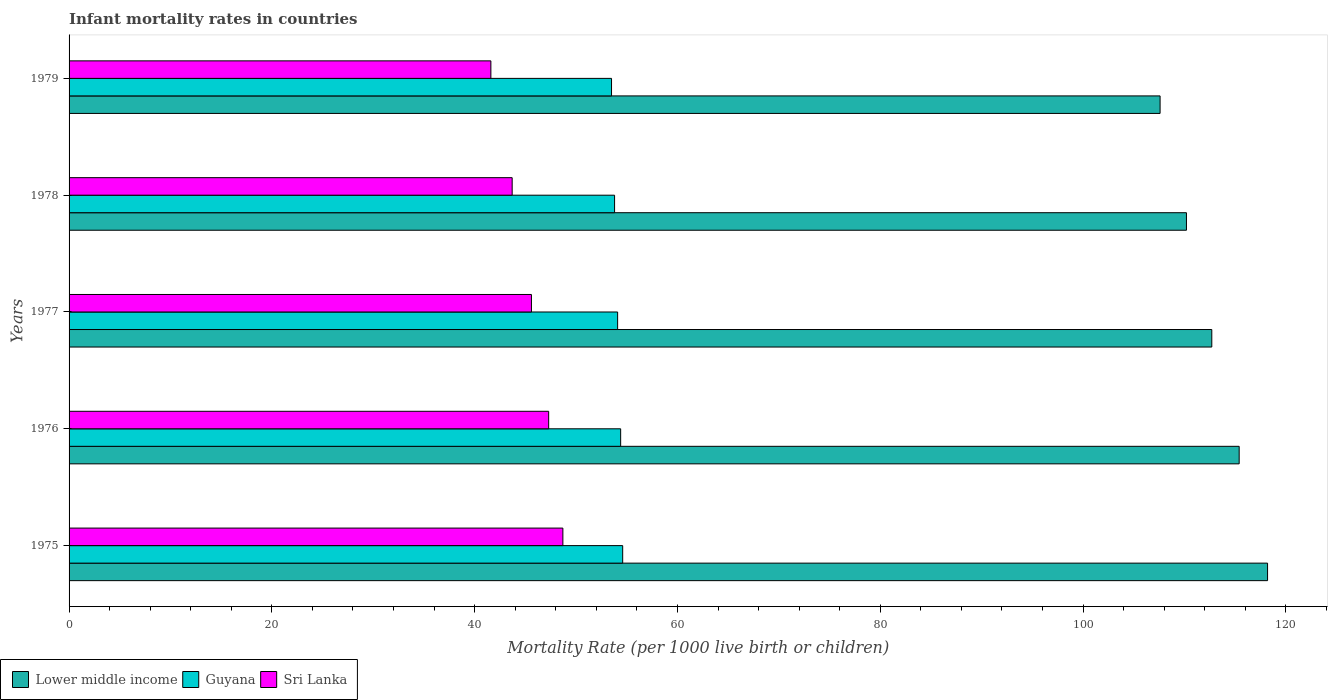How many different coloured bars are there?
Make the answer very short. 3. Are the number of bars per tick equal to the number of legend labels?
Your answer should be compact. Yes. How many bars are there on the 4th tick from the top?
Your answer should be very brief. 3. How many bars are there on the 4th tick from the bottom?
Make the answer very short. 3. What is the label of the 4th group of bars from the top?
Provide a succinct answer. 1976. What is the infant mortality rate in Guyana in 1978?
Offer a terse response. 53.8. Across all years, what is the maximum infant mortality rate in Lower middle income?
Offer a very short reply. 118.2. Across all years, what is the minimum infant mortality rate in Guyana?
Provide a short and direct response. 53.5. In which year was the infant mortality rate in Sri Lanka maximum?
Keep it short and to the point. 1975. In which year was the infant mortality rate in Lower middle income minimum?
Your answer should be very brief. 1979. What is the total infant mortality rate in Lower middle income in the graph?
Give a very brief answer. 564.1. What is the difference between the infant mortality rate in Guyana in 1975 and the infant mortality rate in Sri Lanka in 1976?
Offer a very short reply. 7.3. What is the average infant mortality rate in Lower middle income per year?
Your response must be concise. 112.82. In the year 1979, what is the difference between the infant mortality rate in Guyana and infant mortality rate in Sri Lanka?
Offer a terse response. 11.9. In how many years, is the infant mortality rate in Sri Lanka greater than 72 ?
Your answer should be compact. 0. What is the ratio of the infant mortality rate in Sri Lanka in 1977 to that in 1978?
Provide a short and direct response. 1.04. Is the infant mortality rate in Sri Lanka in 1978 less than that in 1979?
Your answer should be very brief. No. What is the difference between the highest and the second highest infant mortality rate in Lower middle income?
Your answer should be very brief. 2.8. What is the difference between the highest and the lowest infant mortality rate in Lower middle income?
Offer a very short reply. 10.6. What does the 2nd bar from the top in 1976 represents?
Your answer should be compact. Guyana. What does the 3rd bar from the bottom in 1976 represents?
Keep it short and to the point. Sri Lanka. What is the difference between two consecutive major ticks on the X-axis?
Keep it short and to the point. 20. Does the graph contain grids?
Your answer should be very brief. No. How many legend labels are there?
Offer a very short reply. 3. What is the title of the graph?
Offer a very short reply. Infant mortality rates in countries. What is the label or title of the X-axis?
Provide a short and direct response. Mortality Rate (per 1000 live birth or children). What is the Mortality Rate (per 1000 live birth or children) of Lower middle income in 1975?
Provide a short and direct response. 118.2. What is the Mortality Rate (per 1000 live birth or children) of Guyana in 1975?
Provide a succinct answer. 54.6. What is the Mortality Rate (per 1000 live birth or children) of Sri Lanka in 1975?
Give a very brief answer. 48.7. What is the Mortality Rate (per 1000 live birth or children) in Lower middle income in 1976?
Offer a terse response. 115.4. What is the Mortality Rate (per 1000 live birth or children) in Guyana in 1976?
Ensure brevity in your answer.  54.4. What is the Mortality Rate (per 1000 live birth or children) in Sri Lanka in 1976?
Give a very brief answer. 47.3. What is the Mortality Rate (per 1000 live birth or children) of Lower middle income in 1977?
Ensure brevity in your answer.  112.7. What is the Mortality Rate (per 1000 live birth or children) in Guyana in 1977?
Your answer should be very brief. 54.1. What is the Mortality Rate (per 1000 live birth or children) in Sri Lanka in 1977?
Give a very brief answer. 45.6. What is the Mortality Rate (per 1000 live birth or children) of Lower middle income in 1978?
Provide a short and direct response. 110.2. What is the Mortality Rate (per 1000 live birth or children) of Guyana in 1978?
Give a very brief answer. 53.8. What is the Mortality Rate (per 1000 live birth or children) in Sri Lanka in 1978?
Your answer should be compact. 43.7. What is the Mortality Rate (per 1000 live birth or children) in Lower middle income in 1979?
Offer a very short reply. 107.6. What is the Mortality Rate (per 1000 live birth or children) in Guyana in 1979?
Offer a very short reply. 53.5. What is the Mortality Rate (per 1000 live birth or children) in Sri Lanka in 1979?
Offer a very short reply. 41.6. Across all years, what is the maximum Mortality Rate (per 1000 live birth or children) in Lower middle income?
Provide a short and direct response. 118.2. Across all years, what is the maximum Mortality Rate (per 1000 live birth or children) in Guyana?
Ensure brevity in your answer.  54.6. Across all years, what is the maximum Mortality Rate (per 1000 live birth or children) in Sri Lanka?
Ensure brevity in your answer.  48.7. Across all years, what is the minimum Mortality Rate (per 1000 live birth or children) in Lower middle income?
Make the answer very short. 107.6. Across all years, what is the minimum Mortality Rate (per 1000 live birth or children) of Guyana?
Give a very brief answer. 53.5. Across all years, what is the minimum Mortality Rate (per 1000 live birth or children) of Sri Lanka?
Offer a terse response. 41.6. What is the total Mortality Rate (per 1000 live birth or children) in Lower middle income in the graph?
Provide a succinct answer. 564.1. What is the total Mortality Rate (per 1000 live birth or children) of Guyana in the graph?
Provide a short and direct response. 270.4. What is the total Mortality Rate (per 1000 live birth or children) in Sri Lanka in the graph?
Provide a short and direct response. 226.9. What is the difference between the Mortality Rate (per 1000 live birth or children) in Guyana in 1975 and that in 1976?
Your response must be concise. 0.2. What is the difference between the Mortality Rate (per 1000 live birth or children) in Sri Lanka in 1975 and that in 1976?
Offer a very short reply. 1.4. What is the difference between the Mortality Rate (per 1000 live birth or children) in Lower middle income in 1975 and that in 1977?
Offer a terse response. 5.5. What is the difference between the Mortality Rate (per 1000 live birth or children) in Guyana in 1975 and that in 1977?
Provide a succinct answer. 0.5. What is the difference between the Mortality Rate (per 1000 live birth or children) in Lower middle income in 1975 and that in 1978?
Make the answer very short. 8. What is the difference between the Mortality Rate (per 1000 live birth or children) of Guyana in 1975 and that in 1978?
Offer a very short reply. 0.8. What is the difference between the Mortality Rate (per 1000 live birth or children) of Sri Lanka in 1975 and that in 1978?
Your response must be concise. 5. What is the difference between the Mortality Rate (per 1000 live birth or children) in Lower middle income in 1975 and that in 1979?
Ensure brevity in your answer.  10.6. What is the difference between the Mortality Rate (per 1000 live birth or children) in Guyana in 1975 and that in 1979?
Offer a terse response. 1.1. What is the difference between the Mortality Rate (per 1000 live birth or children) in Lower middle income in 1976 and that in 1977?
Your response must be concise. 2.7. What is the difference between the Mortality Rate (per 1000 live birth or children) of Sri Lanka in 1976 and that in 1977?
Ensure brevity in your answer.  1.7. What is the difference between the Mortality Rate (per 1000 live birth or children) of Lower middle income in 1976 and that in 1978?
Your response must be concise. 5.2. What is the difference between the Mortality Rate (per 1000 live birth or children) of Guyana in 1976 and that in 1978?
Keep it short and to the point. 0.6. What is the difference between the Mortality Rate (per 1000 live birth or children) of Sri Lanka in 1976 and that in 1978?
Provide a short and direct response. 3.6. What is the difference between the Mortality Rate (per 1000 live birth or children) in Guyana in 1976 and that in 1979?
Give a very brief answer. 0.9. What is the difference between the Mortality Rate (per 1000 live birth or children) of Lower middle income in 1977 and that in 1978?
Offer a terse response. 2.5. What is the difference between the Mortality Rate (per 1000 live birth or children) in Guyana in 1977 and that in 1978?
Provide a succinct answer. 0.3. What is the difference between the Mortality Rate (per 1000 live birth or children) of Sri Lanka in 1977 and that in 1978?
Your answer should be compact. 1.9. What is the difference between the Mortality Rate (per 1000 live birth or children) of Lower middle income in 1977 and that in 1979?
Offer a very short reply. 5.1. What is the difference between the Mortality Rate (per 1000 live birth or children) in Lower middle income in 1978 and that in 1979?
Make the answer very short. 2.6. What is the difference between the Mortality Rate (per 1000 live birth or children) of Sri Lanka in 1978 and that in 1979?
Offer a terse response. 2.1. What is the difference between the Mortality Rate (per 1000 live birth or children) of Lower middle income in 1975 and the Mortality Rate (per 1000 live birth or children) of Guyana in 1976?
Ensure brevity in your answer.  63.8. What is the difference between the Mortality Rate (per 1000 live birth or children) of Lower middle income in 1975 and the Mortality Rate (per 1000 live birth or children) of Sri Lanka in 1976?
Your answer should be compact. 70.9. What is the difference between the Mortality Rate (per 1000 live birth or children) in Guyana in 1975 and the Mortality Rate (per 1000 live birth or children) in Sri Lanka in 1976?
Keep it short and to the point. 7.3. What is the difference between the Mortality Rate (per 1000 live birth or children) in Lower middle income in 1975 and the Mortality Rate (per 1000 live birth or children) in Guyana in 1977?
Your answer should be very brief. 64.1. What is the difference between the Mortality Rate (per 1000 live birth or children) in Lower middle income in 1975 and the Mortality Rate (per 1000 live birth or children) in Sri Lanka in 1977?
Offer a very short reply. 72.6. What is the difference between the Mortality Rate (per 1000 live birth or children) of Guyana in 1975 and the Mortality Rate (per 1000 live birth or children) of Sri Lanka in 1977?
Your answer should be very brief. 9. What is the difference between the Mortality Rate (per 1000 live birth or children) in Lower middle income in 1975 and the Mortality Rate (per 1000 live birth or children) in Guyana in 1978?
Give a very brief answer. 64.4. What is the difference between the Mortality Rate (per 1000 live birth or children) of Lower middle income in 1975 and the Mortality Rate (per 1000 live birth or children) of Sri Lanka in 1978?
Your answer should be very brief. 74.5. What is the difference between the Mortality Rate (per 1000 live birth or children) in Lower middle income in 1975 and the Mortality Rate (per 1000 live birth or children) in Guyana in 1979?
Your answer should be compact. 64.7. What is the difference between the Mortality Rate (per 1000 live birth or children) in Lower middle income in 1975 and the Mortality Rate (per 1000 live birth or children) in Sri Lanka in 1979?
Provide a succinct answer. 76.6. What is the difference between the Mortality Rate (per 1000 live birth or children) in Lower middle income in 1976 and the Mortality Rate (per 1000 live birth or children) in Guyana in 1977?
Offer a terse response. 61.3. What is the difference between the Mortality Rate (per 1000 live birth or children) of Lower middle income in 1976 and the Mortality Rate (per 1000 live birth or children) of Sri Lanka in 1977?
Offer a terse response. 69.8. What is the difference between the Mortality Rate (per 1000 live birth or children) of Lower middle income in 1976 and the Mortality Rate (per 1000 live birth or children) of Guyana in 1978?
Make the answer very short. 61.6. What is the difference between the Mortality Rate (per 1000 live birth or children) in Lower middle income in 1976 and the Mortality Rate (per 1000 live birth or children) in Sri Lanka in 1978?
Provide a succinct answer. 71.7. What is the difference between the Mortality Rate (per 1000 live birth or children) in Guyana in 1976 and the Mortality Rate (per 1000 live birth or children) in Sri Lanka in 1978?
Ensure brevity in your answer.  10.7. What is the difference between the Mortality Rate (per 1000 live birth or children) in Lower middle income in 1976 and the Mortality Rate (per 1000 live birth or children) in Guyana in 1979?
Give a very brief answer. 61.9. What is the difference between the Mortality Rate (per 1000 live birth or children) in Lower middle income in 1976 and the Mortality Rate (per 1000 live birth or children) in Sri Lanka in 1979?
Make the answer very short. 73.8. What is the difference between the Mortality Rate (per 1000 live birth or children) of Lower middle income in 1977 and the Mortality Rate (per 1000 live birth or children) of Guyana in 1978?
Keep it short and to the point. 58.9. What is the difference between the Mortality Rate (per 1000 live birth or children) in Guyana in 1977 and the Mortality Rate (per 1000 live birth or children) in Sri Lanka in 1978?
Your response must be concise. 10.4. What is the difference between the Mortality Rate (per 1000 live birth or children) of Lower middle income in 1977 and the Mortality Rate (per 1000 live birth or children) of Guyana in 1979?
Your answer should be very brief. 59.2. What is the difference between the Mortality Rate (per 1000 live birth or children) in Lower middle income in 1977 and the Mortality Rate (per 1000 live birth or children) in Sri Lanka in 1979?
Your response must be concise. 71.1. What is the difference between the Mortality Rate (per 1000 live birth or children) in Guyana in 1977 and the Mortality Rate (per 1000 live birth or children) in Sri Lanka in 1979?
Offer a terse response. 12.5. What is the difference between the Mortality Rate (per 1000 live birth or children) of Lower middle income in 1978 and the Mortality Rate (per 1000 live birth or children) of Guyana in 1979?
Offer a very short reply. 56.7. What is the difference between the Mortality Rate (per 1000 live birth or children) in Lower middle income in 1978 and the Mortality Rate (per 1000 live birth or children) in Sri Lanka in 1979?
Offer a very short reply. 68.6. What is the average Mortality Rate (per 1000 live birth or children) of Lower middle income per year?
Your answer should be compact. 112.82. What is the average Mortality Rate (per 1000 live birth or children) of Guyana per year?
Your response must be concise. 54.08. What is the average Mortality Rate (per 1000 live birth or children) in Sri Lanka per year?
Make the answer very short. 45.38. In the year 1975, what is the difference between the Mortality Rate (per 1000 live birth or children) of Lower middle income and Mortality Rate (per 1000 live birth or children) of Guyana?
Give a very brief answer. 63.6. In the year 1975, what is the difference between the Mortality Rate (per 1000 live birth or children) of Lower middle income and Mortality Rate (per 1000 live birth or children) of Sri Lanka?
Provide a short and direct response. 69.5. In the year 1976, what is the difference between the Mortality Rate (per 1000 live birth or children) of Lower middle income and Mortality Rate (per 1000 live birth or children) of Guyana?
Your answer should be compact. 61. In the year 1976, what is the difference between the Mortality Rate (per 1000 live birth or children) of Lower middle income and Mortality Rate (per 1000 live birth or children) of Sri Lanka?
Make the answer very short. 68.1. In the year 1977, what is the difference between the Mortality Rate (per 1000 live birth or children) in Lower middle income and Mortality Rate (per 1000 live birth or children) in Guyana?
Give a very brief answer. 58.6. In the year 1977, what is the difference between the Mortality Rate (per 1000 live birth or children) of Lower middle income and Mortality Rate (per 1000 live birth or children) of Sri Lanka?
Give a very brief answer. 67.1. In the year 1978, what is the difference between the Mortality Rate (per 1000 live birth or children) of Lower middle income and Mortality Rate (per 1000 live birth or children) of Guyana?
Offer a very short reply. 56.4. In the year 1978, what is the difference between the Mortality Rate (per 1000 live birth or children) of Lower middle income and Mortality Rate (per 1000 live birth or children) of Sri Lanka?
Your answer should be compact. 66.5. In the year 1978, what is the difference between the Mortality Rate (per 1000 live birth or children) in Guyana and Mortality Rate (per 1000 live birth or children) in Sri Lanka?
Provide a succinct answer. 10.1. In the year 1979, what is the difference between the Mortality Rate (per 1000 live birth or children) of Lower middle income and Mortality Rate (per 1000 live birth or children) of Guyana?
Give a very brief answer. 54.1. In the year 1979, what is the difference between the Mortality Rate (per 1000 live birth or children) of Lower middle income and Mortality Rate (per 1000 live birth or children) of Sri Lanka?
Your answer should be compact. 66. In the year 1979, what is the difference between the Mortality Rate (per 1000 live birth or children) in Guyana and Mortality Rate (per 1000 live birth or children) in Sri Lanka?
Ensure brevity in your answer.  11.9. What is the ratio of the Mortality Rate (per 1000 live birth or children) of Lower middle income in 1975 to that in 1976?
Offer a terse response. 1.02. What is the ratio of the Mortality Rate (per 1000 live birth or children) of Sri Lanka in 1975 to that in 1976?
Give a very brief answer. 1.03. What is the ratio of the Mortality Rate (per 1000 live birth or children) of Lower middle income in 1975 to that in 1977?
Your answer should be very brief. 1.05. What is the ratio of the Mortality Rate (per 1000 live birth or children) of Guyana in 1975 to that in 1977?
Make the answer very short. 1.01. What is the ratio of the Mortality Rate (per 1000 live birth or children) of Sri Lanka in 1975 to that in 1977?
Give a very brief answer. 1.07. What is the ratio of the Mortality Rate (per 1000 live birth or children) of Lower middle income in 1975 to that in 1978?
Offer a very short reply. 1.07. What is the ratio of the Mortality Rate (per 1000 live birth or children) in Guyana in 1975 to that in 1978?
Make the answer very short. 1.01. What is the ratio of the Mortality Rate (per 1000 live birth or children) in Sri Lanka in 1975 to that in 1978?
Provide a succinct answer. 1.11. What is the ratio of the Mortality Rate (per 1000 live birth or children) in Lower middle income in 1975 to that in 1979?
Ensure brevity in your answer.  1.1. What is the ratio of the Mortality Rate (per 1000 live birth or children) in Guyana in 1975 to that in 1979?
Offer a terse response. 1.02. What is the ratio of the Mortality Rate (per 1000 live birth or children) of Sri Lanka in 1975 to that in 1979?
Your response must be concise. 1.17. What is the ratio of the Mortality Rate (per 1000 live birth or children) of Lower middle income in 1976 to that in 1977?
Provide a short and direct response. 1.02. What is the ratio of the Mortality Rate (per 1000 live birth or children) of Guyana in 1976 to that in 1977?
Provide a succinct answer. 1.01. What is the ratio of the Mortality Rate (per 1000 live birth or children) of Sri Lanka in 1976 to that in 1977?
Make the answer very short. 1.04. What is the ratio of the Mortality Rate (per 1000 live birth or children) of Lower middle income in 1976 to that in 1978?
Provide a short and direct response. 1.05. What is the ratio of the Mortality Rate (per 1000 live birth or children) in Guyana in 1976 to that in 1978?
Ensure brevity in your answer.  1.01. What is the ratio of the Mortality Rate (per 1000 live birth or children) in Sri Lanka in 1976 to that in 1978?
Offer a terse response. 1.08. What is the ratio of the Mortality Rate (per 1000 live birth or children) of Lower middle income in 1976 to that in 1979?
Provide a succinct answer. 1.07. What is the ratio of the Mortality Rate (per 1000 live birth or children) of Guyana in 1976 to that in 1979?
Ensure brevity in your answer.  1.02. What is the ratio of the Mortality Rate (per 1000 live birth or children) in Sri Lanka in 1976 to that in 1979?
Provide a succinct answer. 1.14. What is the ratio of the Mortality Rate (per 1000 live birth or children) of Lower middle income in 1977 to that in 1978?
Provide a short and direct response. 1.02. What is the ratio of the Mortality Rate (per 1000 live birth or children) of Guyana in 1977 to that in 1978?
Your answer should be very brief. 1.01. What is the ratio of the Mortality Rate (per 1000 live birth or children) in Sri Lanka in 1977 to that in 1978?
Keep it short and to the point. 1.04. What is the ratio of the Mortality Rate (per 1000 live birth or children) in Lower middle income in 1977 to that in 1979?
Your answer should be very brief. 1.05. What is the ratio of the Mortality Rate (per 1000 live birth or children) in Guyana in 1977 to that in 1979?
Give a very brief answer. 1.01. What is the ratio of the Mortality Rate (per 1000 live birth or children) of Sri Lanka in 1977 to that in 1979?
Offer a terse response. 1.1. What is the ratio of the Mortality Rate (per 1000 live birth or children) of Lower middle income in 1978 to that in 1979?
Ensure brevity in your answer.  1.02. What is the ratio of the Mortality Rate (per 1000 live birth or children) of Guyana in 1978 to that in 1979?
Offer a very short reply. 1.01. What is the ratio of the Mortality Rate (per 1000 live birth or children) of Sri Lanka in 1978 to that in 1979?
Keep it short and to the point. 1.05. What is the difference between the highest and the second highest Mortality Rate (per 1000 live birth or children) in Sri Lanka?
Offer a terse response. 1.4. What is the difference between the highest and the lowest Mortality Rate (per 1000 live birth or children) in Lower middle income?
Your answer should be very brief. 10.6. What is the difference between the highest and the lowest Mortality Rate (per 1000 live birth or children) of Guyana?
Provide a succinct answer. 1.1. What is the difference between the highest and the lowest Mortality Rate (per 1000 live birth or children) of Sri Lanka?
Ensure brevity in your answer.  7.1. 